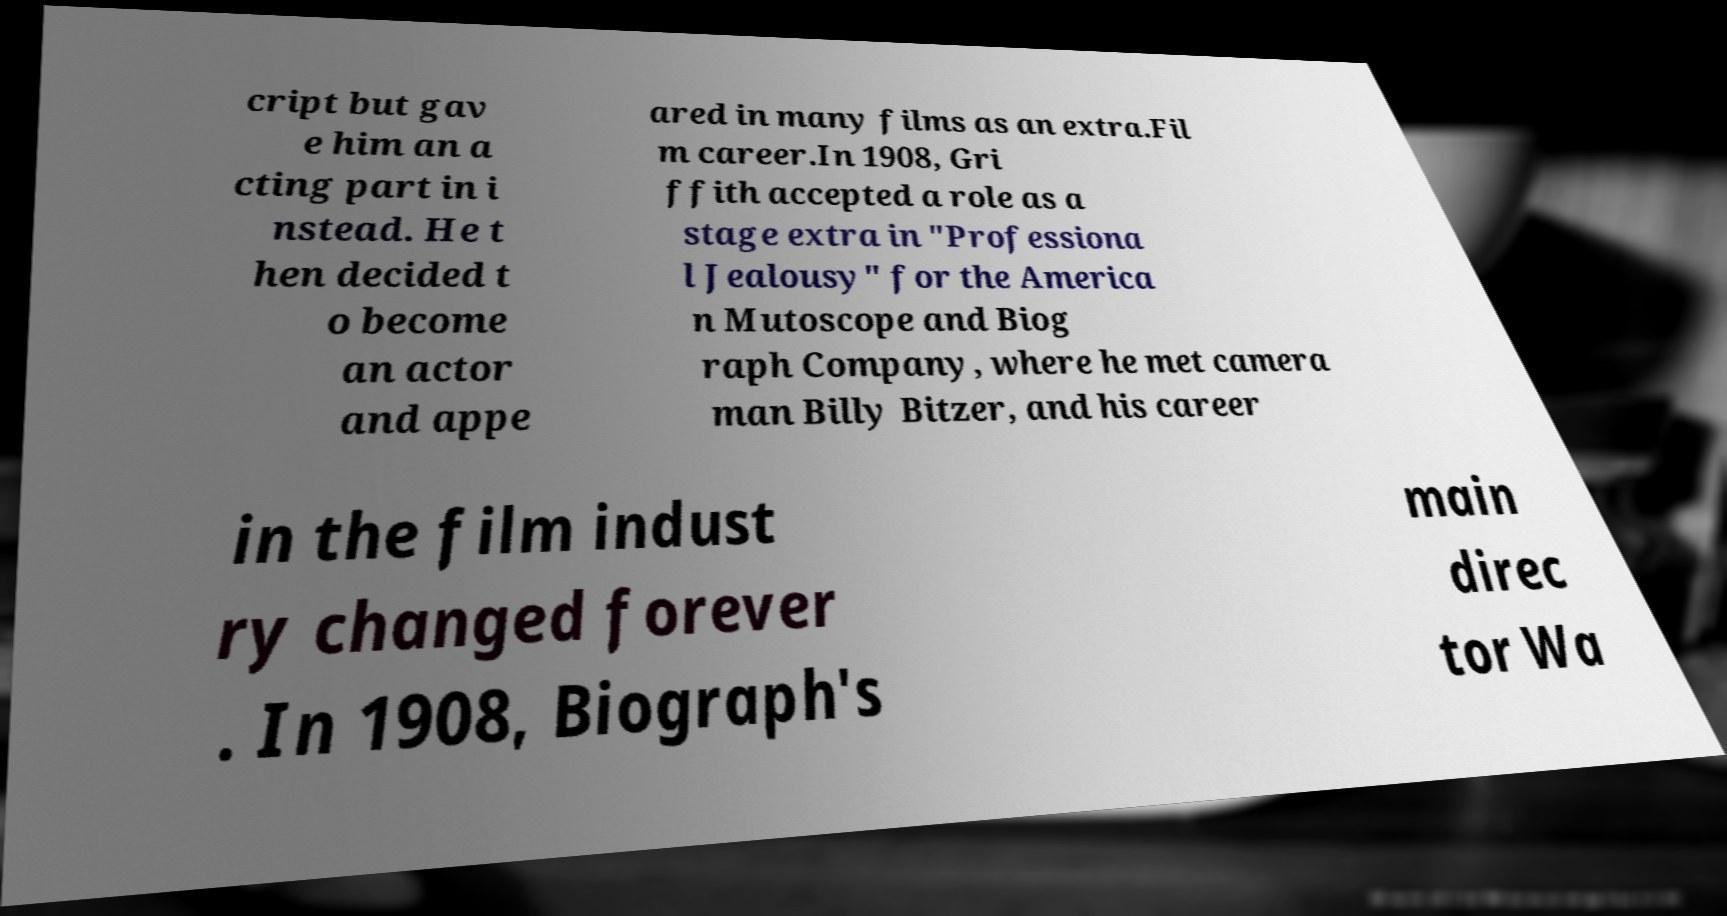There's text embedded in this image that I need extracted. Can you transcribe it verbatim? cript but gav e him an a cting part in i nstead. He t hen decided t o become an actor and appe ared in many films as an extra.Fil m career.In 1908, Gri ffith accepted a role as a stage extra in "Professiona l Jealousy" for the America n Mutoscope and Biog raph Company, where he met camera man Billy Bitzer, and his career in the film indust ry changed forever . In 1908, Biograph's main direc tor Wa 